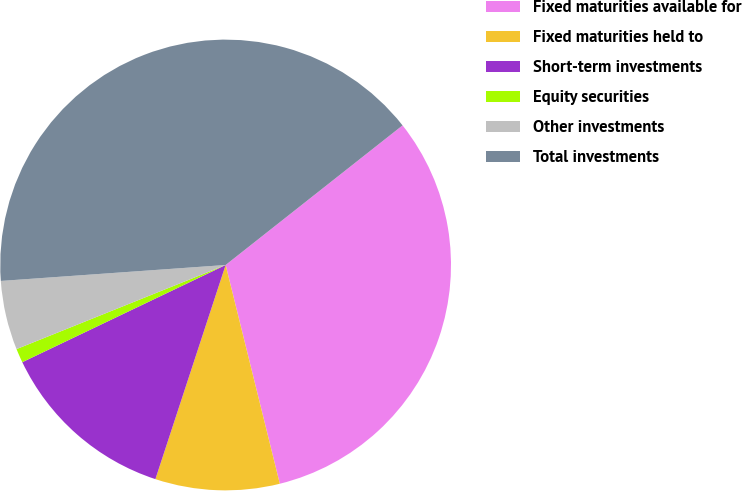<chart> <loc_0><loc_0><loc_500><loc_500><pie_chart><fcel>Fixed maturities available for<fcel>Fixed maturities held to<fcel>Short-term investments<fcel>Equity securities<fcel>Other investments<fcel>Total investments<nl><fcel>31.77%<fcel>8.91%<fcel>12.86%<fcel>1.01%<fcel>4.96%<fcel>40.5%<nl></chart> 